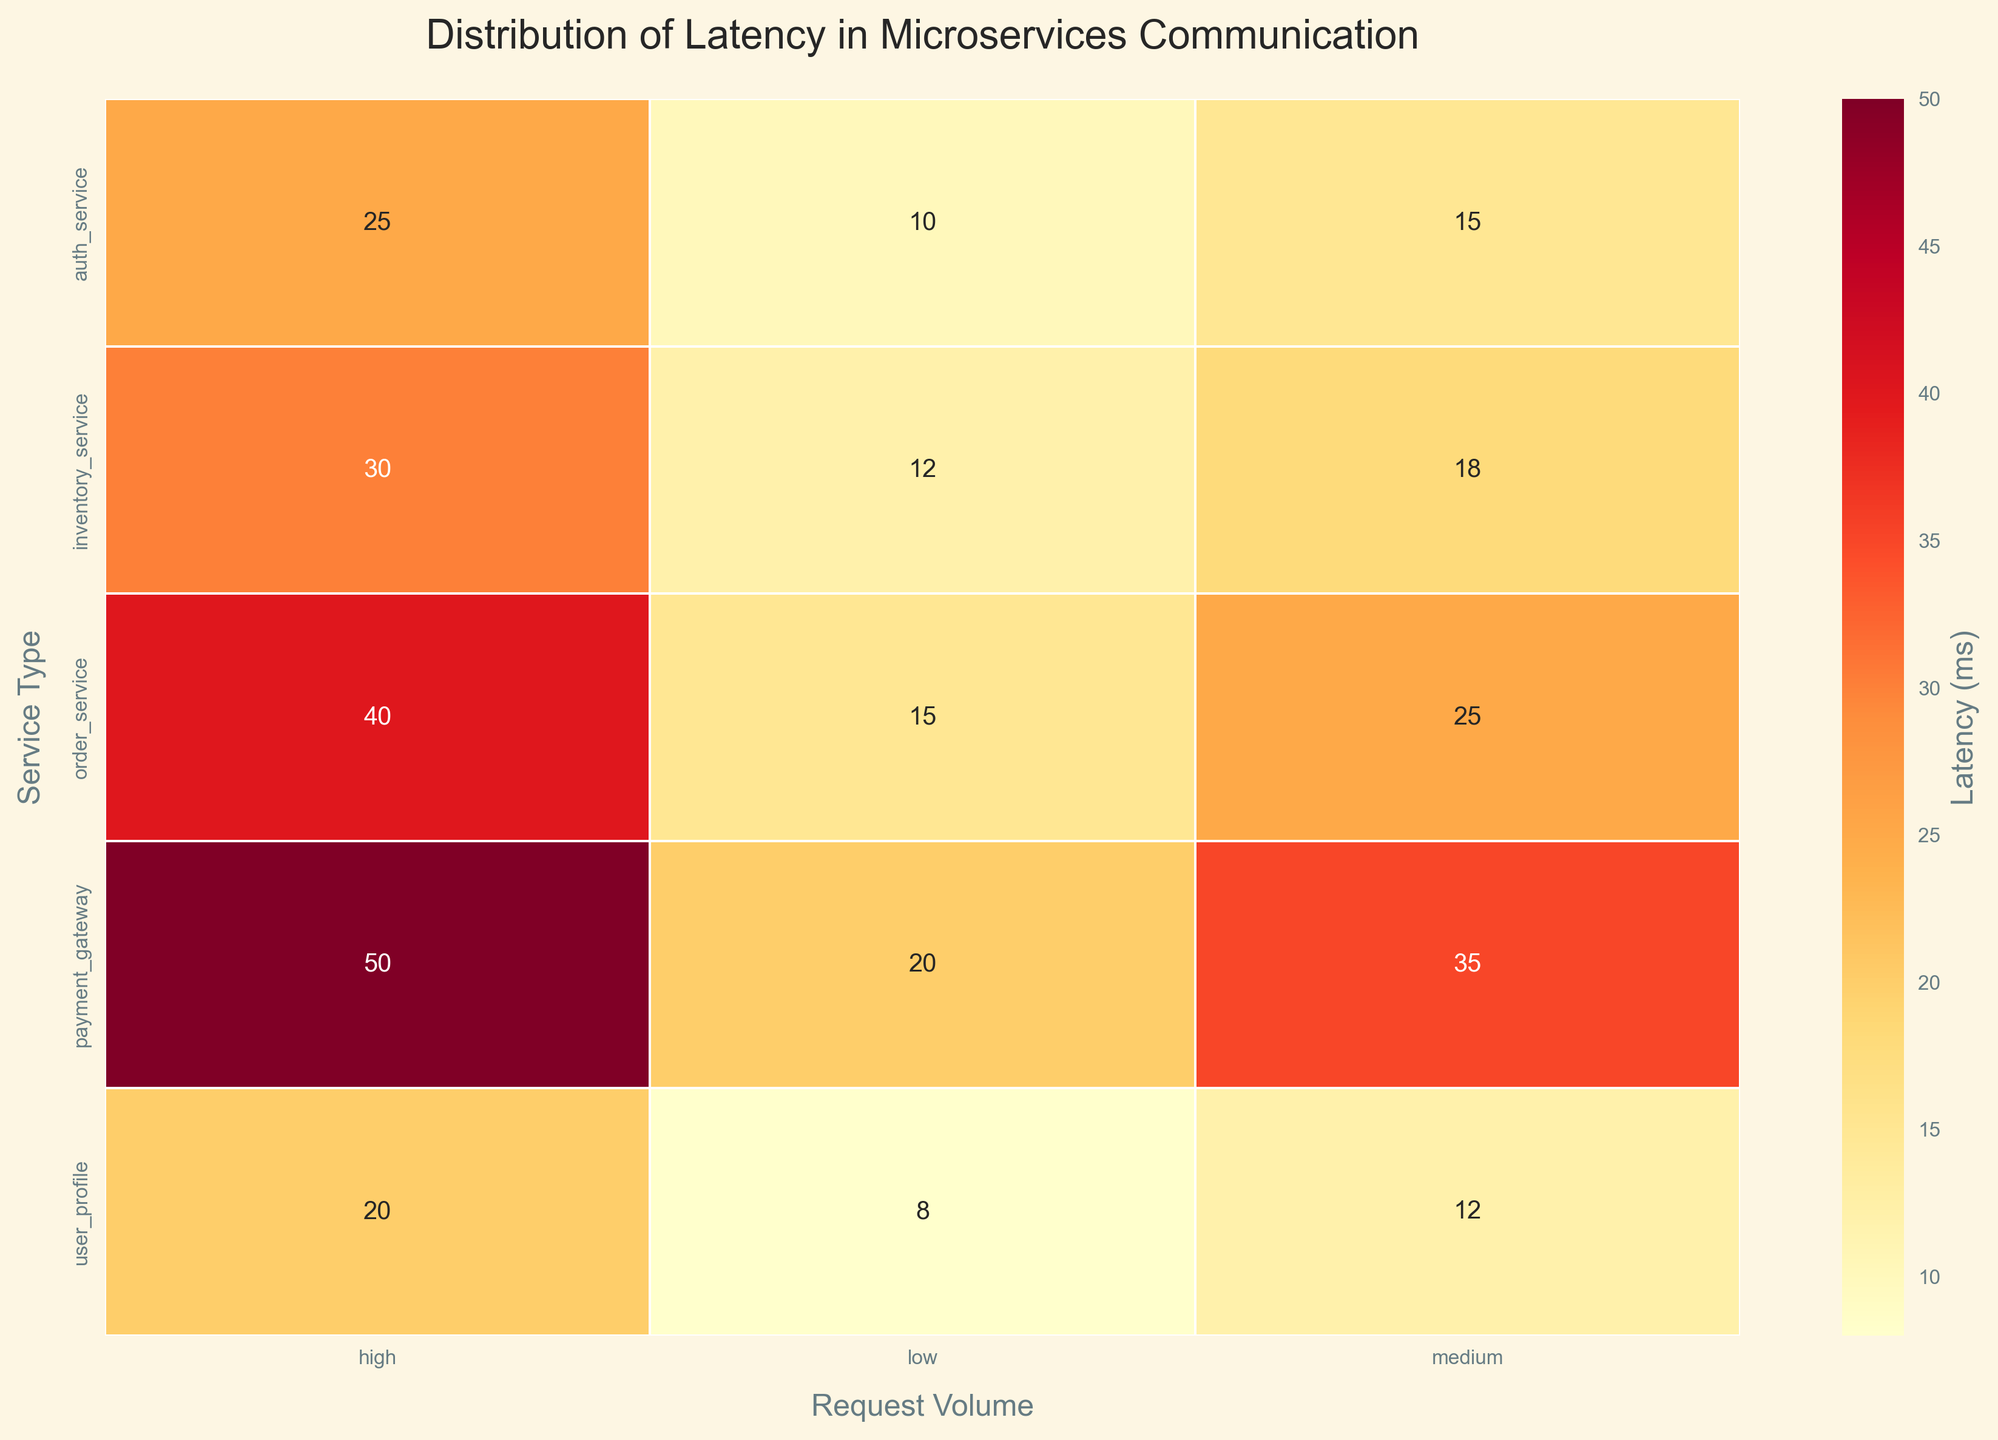What is the title of the heatmap? The title of the heatmap is written at the top of the figure.
Answer: Distribution of Latency in Microservices Communication What are the request volume categories displayed on the x-axis? The x-axis lists the request volume categories.
Answer: Low, Medium, High Which service type has the lowest latency for low request volume? By scanning the heatmap's cells in the 'Low' request volume column, find the minimum latency value and check the corresponding service type row.
Answer: User_Profile What is the latency of the Payment Gateway service at medium request volume? Locate the cell in the intersecting position of 'Payment Gateway' and 'Medium' request volume.
Answer: 35 ms Which service type experiences the highest latency at high request volume? Look at the values in the 'High' request volume column and identify the maximum value, then find the corresponding service type row.
Answer: Payment Gateway For which request volume does Inventory Service have the highest latency? Check the row for 'Inventory Service' and find the column with the maximum value.
Answer: High request volume How much higher is the latency of Order Service at high request volume compared to low request volume? Subtract the value for 'Low' request volume from 'High' request volume in the 'Order Service' row to find the difference.
Answer: 25 ms Compare the latency of Auth Service and User Profile at medium request volume. Which has lower latency and by how much? Locate the values for 'Auth Service' and 'User Profile' in the 'Medium' request volume column. Subtract the lower value from the higher value.
Answer: User Profile has lower latency by 3 ms What is the average latency of the Payment Gateway service across all request volumes? Sum the latency values for 'Payment Gateway' at all request volumes and divide by the number of request volumes (3).
Answer: 35 ms If you rank the services by their highest latency values, what positions do Auth Service and Order Service occupy? List the maximum latency values for each service, then rank them in descending order and locate the positions of 'Auth Service' and 'Order Service'.
Answer: Auth Service is 4th, Order Service is 3rd 